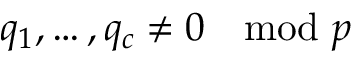Convert formula to latex. <formula><loc_0><loc_0><loc_500><loc_500>q _ { 1 } , \dots , q _ { c } \neq 0 \mod p</formula> 